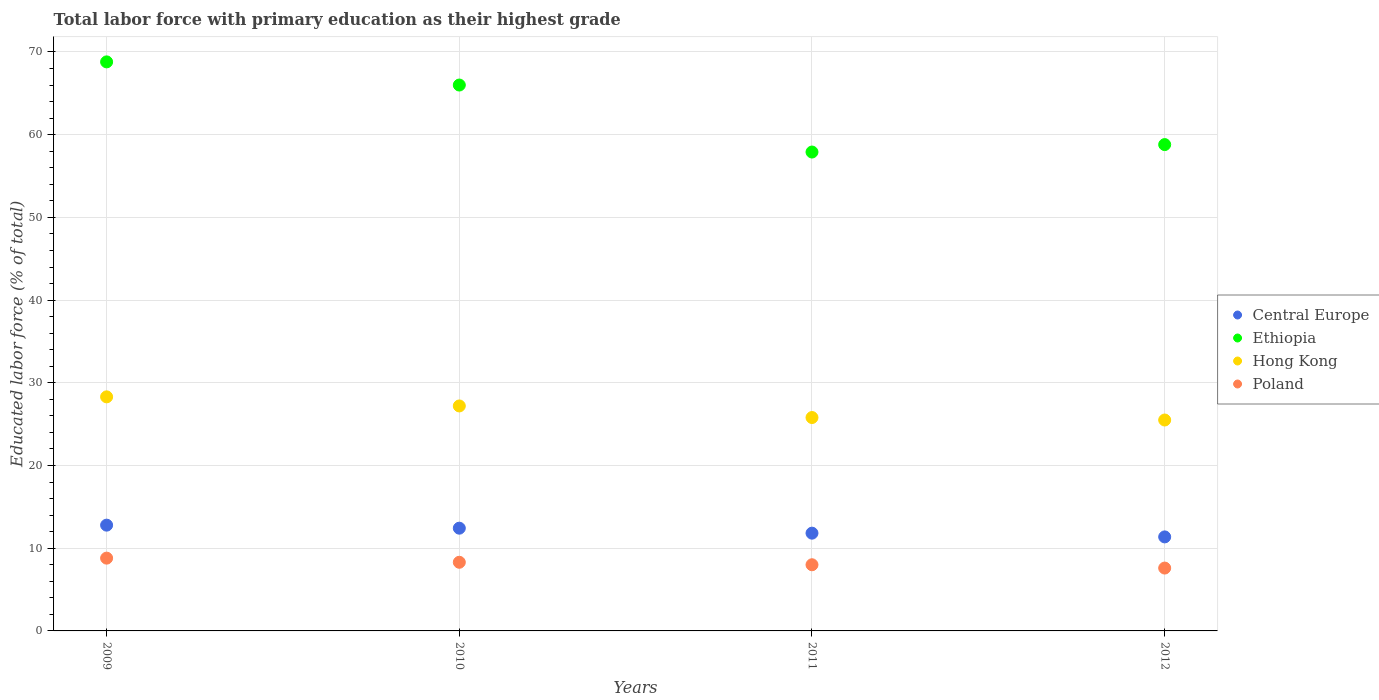How many different coloured dotlines are there?
Your answer should be compact. 4. Is the number of dotlines equal to the number of legend labels?
Keep it short and to the point. Yes. What is the percentage of total labor force with primary education in Ethiopia in 2012?
Make the answer very short. 58.8. Across all years, what is the maximum percentage of total labor force with primary education in Central Europe?
Keep it short and to the point. 12.79. Across all years, what is the minimum percentage of total labor force with primary education in Central Europe?
Provide a short and direct response. 11.37. In which year was the percentage of total labor force with primary education in Central Europe minimum?
Provide a short and direct response. 2012. What is the total percentage of total labor force with primary education in Poland in the graph?
Provide a succinct answer. 32.7. What is the difference between the percentage of total labor force with primary education in Poland in 2009 and that in 2011?
Offer a terse response. 0.8. What is the difference between the percentage of total labor force with primary education in Central Europe in 2011 and the percentage of total labor force with primary education in Ethiopia in 2010?
Your response must be concise. -54.18. What is the average percentage of total labor force with primary education in Hong Kong per year?
Provide a succinct answer. 26.7. In the year 2011, what is the difference between the percentage of total labor force with primary education in Central Europe and percentage of total labor force with primary education in Ethiopia?
Keep it short and to the point. -46.08. In how many years, is the percentage of total labor force with primary education in Poland greater than 28 %?
Ensure brevity in your answer.  0. What is the ratio of the percentage of total labor force with primary education in Ethiopia in 2010 to that in 2012?
Provide a succinct answer. 1.12. Is the difference between the percentage of total labor force with primary education in Central Europe in 2009 and 2011 greater than the difference between the percentage of total labor force with primary education in Ethiopia in 2009 and 2011?
Make the answer very short. No. What is the difference between the highest and the second highest percentage of total labor force with primary education in Central Europe?
Give a very brief answer. 0.37. What is the difference between the highest and the lowest percentage of total labor force with primary education in Poland?
Your response must be concise. 1.2. In how many years, is the percentage of total labor force with primary education in Central Europe greater than the average percentage of total labor force with primary education in Central Europe taken over all years?
Your response must be concise. 2. Is it the case that in every year, the sum of the percentage of total labor force with primary education in Central Europe and percentage of total labor force with primary education in Poland  is greater than the percentage of total labor force with primary education in Hong Kong?
Offer a very short reply. No. Is the percentage of total labor force with primary education in Ethiopia strictly greater than the percentage of total labor force with primary education in Poland over the years?
Make the answer very short. Yes. Is the percentage of total labor force with primary education in Central Europe strictly less than the percentage of total labor force with primary education in Hong Kong over the years?
Give a very brief answer. Yes. What is the difference between two consecutive major ticks on the Y-axis?
Keep it short and to the point. 10. Are the values on the major ticks of Y-axis written in scientific E-notation?
Make the answer very short. No. Does the graph contain any zero values?
Make the answer very short. No. How many legend labels are there?
Offer a terse response. 4. How are the legend labels stacked?
Your answer should be compact. Vertical. What is the title of the graph?
Make the answer very short. Total labor force with primary education as their highest grade. Does "Uzbekistan" appear as one of the legend labels in the graph?
Give a very brief answer. No. What is the label or title of the X-axis?
Your response must be concise. Years. What is the label or title of the Y-axis?
Give a very brief answer. Educated labor force (% of total). What is the Educated labor force (% of total) in Central Europe in 2009?
Your response must be concise. 12.79. What is the Educated labor force (% of total) of Ethiopia in 2009?
Offer a very short reply. 68.8. What is the Educated labor force (% of total) of Hong Kong in 2009?
Provide a succinct answer. 28.3. What is the Educated labor force (% of total) in Poland in 2009?
Keep it short and to the point. 8.8. What is the Educated labor force (% of total) of Central Europe in 2010?
Ensure brevity in your answer.  12.42. What is the Educated labor force (% of total) in Hong Kong in 2010?
Your answer should be very brief. 27.2. What is the Educated labor force (% of total) in Poland in 2010?
Make the answer very short. 8.3. What is the Educated labor force (% of total) in Central Europe in 2011?
Provide a succinct answer. 11.82. What is the Educated labor force (% of total) of Ethiopia in 2011?
Offer a very short reply. 57.9. What is the Educated labor force (% of total) in Hong Kong in 2011?
Ensure brevity in your answer.  25.8. What is the Educated labor force (% of total) of Central Europe in 2012?
Provide a succinct answer. 11.37. What is the Educated labor force (% of total) of Ethiopia in 2012?
Give a very brief answer. 58.8. What is the Educated labor force (% of total) of Poland in 2012?
Make the answer very short. 7.6. Across all years, what is the maximum Educated labor force (% of total) in Central Europe?
Your answer should be compact. 12.79. Across all years, what is the maximum Educated labor force (% of total) of Ethiopia?
Make the answer very short. 68.8. Across all years, what is the maximum Educated labor force (% of total) of Hong Kong?
Ensure brevity in your answer.  28.3. Across all years, what is the maximum Educated labor force (% of total) in Poland?
Ensure brevity in your answer.  8.8. Across all years, what is the minimum Educated labor force (% of total) of Central Europe?
Offer a terse response. 11.37. Across all years, what is the minimum Educated labor force (% of total) in Ethiopia?
Offer a very short reply. 57.9. Across all years, what is the minimum Educated labor force (% of total) in Poland?
Offer a terse response. 7.6. What is the total Educated labor force (% of total) of Central Europe in the graph?
Make the answer very short. 48.4. What is the total Educated labor force (% of total) of Ethiopia in the graph?
Provide a short and direct response. 251.5. What is the total Educated labor force (% of total) of Hong Kong in the graph?
Your answer should be compact. 106.8. What is the total Educated labor force (% of total) of Poland in the graph?
Offer a very short reply. 32.7. What is the difference between the Educated labor force (% of total) in Central Europe in 2009 and that in 2010?
Provide a succinct answer. 0.37. What is the difference between the Educated labor force (% of total) of Hong Kong in 2009 and that in 2010?
Keep it short and to the point. 1.1. What is the difference between the Educated labor force (% of total) in Central Europe in 2009 and that in 2011?
Make the answer very short. 0.97. What is the difference between the Educated labor force (% of total) in Ethiopia in 2009 and that in 2011?
Make the answer very short. 10.9. What is the difference between the Educated labor force (% of total) of Hong Kong in 2009 and that in 2011?
Offer a terse response. 2.5. What is the difference between the Educated labor force (% of total) in Poland in 2009 and that in 2011?
Keep it short and to the point. 0.8. What is the difference between the Educated labor force (% of total) in Central Europe in 2009 and that in 2012?
Your response must be concise. 1.42. What is the difference between the Educated labor force (% of total) of Poland in 2009 and that in 2012?
Give a very brief answer. 1.2. What is the difference between the Educated labor force (% of total) of Central Europe in 2010 and that in 2011?
Your response must be concise. 0.6. What is the difference between the Educated labor force (% of total) in Poland in 2010 and that in 2011?
Make the answer very short. 0.3. What is the difference between the Educated labor force (% of total) in Central Europe in 2010 and that in 2012?
Give a very brief answer. 1.05. What is the difference between the Educated labor force (% of total) of Ethiopia in 2010 and that in 2012?
Ensure brevity in your answer.  7.2. What is the difference between the Educated labor force (% of total) in Central Europe in 2011 and that in 2012?
Provide a succinct answer. 0.45. What is the difference between the Educated labor force (% of total) of Ethiopia in 2011 and that in 2012?
Offer a terse response. -0.9. What is the difference between the Educated labor force (% of total) in Central Europe in 2009 and the Educated labor force (% of total) in Ethiopia in 2010?
Make the answer very short. -53.21. What is the difference between the Educated labor force (% of total) of Central Europe in 2009 and the Educated labor force (% of total) of Hong Kong in 2010?
Your answer should be compact. -14.41. What is the difference between the Educated labor force (% of total) in Central Europe in 2009 and the Educated labor force (% of total) in Poland in 2010?
Ensure brevity in your answer.  4.49. What is the difference between the Educated labor force (% of total) of Ethiopia in 2009 and the Educated labor force (% of total) of Hong Kong in 2010?
Offer a terse response. 41.6. What is the difference between the Educated labor force (% of total) of Ethiopia in 2009 and the Educated labor force (% of total) of Poland in 2010?
Provide a short and direct response. 60.5. What is the difference between the Educated labor force (% of total) of Central Europe in 2009 and the Educated labor force (% of total) of Ethiopia in 2011?
Ensure brevity in your answer.  -45.11. What is the difference between the Educated labor force (% of total) of Central Europe in 2009 and the Educated labor force (% of total) of Hong Kong in 2011?
Your response must be concise. -13.01. What is the difference between the Educated labor force (% of total) in Central Europe in 2009 and the Educated labor force (% of total) in Poland in 2011?
Provide a short and direct response. 4.79. What is the difference between the Educated labor force (% of total) in Ethiopia in 2009 and the Educated labor force (% of total) in Hong Kong in 2011?
Offer a very short reply. 43. What is the difference between the Educated labor force (% of total) in Ethiopia in 2009 and the Educated labor force (% of total) in Poland in 2011?
Keep it short and to the point. 60.8. What is the difference between the Educated labor force (% of total) of Hong Kong in 2009 and the Educated labor force (% of total) of Poland in 2011?
Your response must be concise. 20.3. What is the difference between the Educated labor force (% of total) of Central Europe in 2009 and the Educated labor force (% of total) of Ethiopia in 2012?
Your response must be concise. -46.01. What is the difference between the Educated labor force (% of total) of Central Europe in 2009 and the Educated labor force (% of total) of Hong Kong in 2012?
Your response must be concise. -12.71. What is the difference between the Educated labor force (% of total) of Central Europe in 2009 and the Educated labor force (% of total) of Poland in 2012?
Ensure brevity in your answer.  5.19. What is the difference between the Educated labor force (% of total) in Ethiopia in 2009 and the Educated labor force (% of total) in Hong Kong in 2012?
Your response must be concise. 43.3. What is the difference between the Educated labor force (% of total) of Ethiopia in 2009 and the Educated labor force (% of total) of Poland in 2012?
Offer a very short reply. 61.2. What is the difference between the Educated labor force (% of total) in Hong Kong in 2009 and the Educated labor force (% of total) in Poland in 2012?
Offer a very short reply. 20.7. What is the difference between the Educated labor force (% of total) in Central Europe in 2010 and the Educated labor force (% of total) in Ethiopia in 2011?
Provide a succinct answer. -45.48. What is the difference between the Educated labor force (% of total) of Central Europe in 2010 and the Educated labor force (% of total) of Hong Kong in 2011?
Ensure brevity in your answer.  -13.38. What is the difference between the Educated labor force (% of total) of Central Europe in 2010 and the Educated labor force (% of total) of Poland in 2011?
Give a very brief answer. 4.42. What is the difference between the Educated labor force (% of total) of Ethiopia in 2010 and the Educated labor force (% of total) of Hong Kong in 2011?
Your answer should be compact. 40.2. What is the difference between the Educated labor force (% of total) of Ethiopia in 2010 and the Educated labor force (% of total) of Poland in 2011?
Keep it short and to the point. 58. What is the difference between the Educated labor force (% of total) of Central Europe in 2010 and the Educated labor force (% of total) of Ethiopia in 2012?
Give a very brief answer. -46.38. What is the difference between the Educated labor force (% of total) of Central Europe in 2010 and the Educated labor force (% of total) of Hong Kong in 2012?
Offer a very short reply. -13.08. What is the difference between the Educated labor force (% of total) of Central Europe in 2010 and the Educated labor force (% of total) of Poland in 2012?
Keep it short and to the point. 4.82. What is the difference between the Educated labor force (% of total) of Ethiopia in 2010 and the Educated labor force (% of total) of Hong Kong in 2012?
Ensure brevity in your answer.  40.5. What is the difference between the Educated labor force (% of total) in Ethiopia in 2010 and the Educated labor force (% of total) in Poland in 2012?
Keep it short and to the point. 58.4. What is the difference between the Educated labor force (% of total) of Hong Kong in 2010 and the Educated labor force (% of total) of Poland in 2012?
Provide a succinct answer. 19.6. What is the difference between the Educated labor force (% of total) in Central Europe in 2011 and the Educated labor force (% of total) in Ethiopia in 2012?
Your answer should be compact. -46.98. What is the difference between the Educated labor force (% of total) of Central Europe in 2011 and the Educated labor force (% of total) of Hong Kong in 2012?
Keep it short and to the point. -13.68. What is the difference between the Educated labor force (% of total) in Central Europe in 2011 and the Educated labor force (% of total) in Poland in 2012?
Make the answer very short. 4.22. What is the difference between the Educated labor force (% of total) in Ethiopia in 2011 and the Educated labor force (% of total) in Hong Kong in 2012?
Keep it short and to the point. 32.4. What is the difference between the Educated labor force (% of total) of Ethiopia in 2011 and the Educated labor force (% of total) of Poland in 2012?
Your answer should be compact. 50.3. What is the difference between the Educated labor force (% of total) of Hong Kong in 2011 and the Educated labor force (% of total) of Poland in 2012?
Make the answer very short. 18.2. What is the average Educated labor force (% of total) of Central Europe per year?
Give a very brief answer. 12.1. What is the average Educated labor force (% of total) in Ethiopia per year?
Ensure brevity in your answer.  62.88. What is the average Educated labor force (% of total) of Hong Kong per year?
Offer a very short reply. 26.7. What is the average Educated labor force (% of total) of Poland per year?
Offer a very short reply. 8.18. In the year 2009, what is the difference between the Educated labor force (% of total) of Central Europe and Educated labor force (% of total) of Ethiopia?
Your response must be concise. -56.01. In the year 2009, what is the difference between the Educated labor force (% of total) in Central Europe and Educated labor force (% of total) in Hong Kong?
Your answer should be very brief. -15.51. In the year 2009, what is the difference between the Educated labor force (% of total) of Central Europe and Educated labor force (% of total) of Poland?
Give a very brief answer. 3.99. In the year 2009, what is the difference between the Educated labor force (% of total) of Ethiopia and Educated labor force (% of total) of Hong Kong?
Offer a terse response. 40.5. In the year 2009, what is the difference between the Educated labor force (% of total) of Ethiopia and Educated labor force (% of total) of Poland?
Ensure brevity in your answer.  60. In the year 2009, what is the difference between the Educated labor force (% of total) in Hong Kong and Educated labor force (% of total) in Poland?
Keep it short and to the point. 19.5. In the year 2010, what is the difference between the Educated labor force (% of total) of Central Europe and Educated labor force (% of total) of Ethiopia?
Offer a very short reply. -53.58. In the year 2010, what is the difference between the Educated labor force (% of total) in Central Europe and Educated labor force (% of total) in Hong Kong?
Your answer should be very brief. -14.78. In the year 2010, what is the difference between the Educated labor force (% of total) in Central Europe and Educated labor force (% of total) in Poland?
Ensure brevity in your answer.  4.12. In the year 2010, what is the difference between the Educated labor force (% of total) in Ethiopia and Educated labor force (% of total) in Hong Kong?
Provide a succinct answer. 38.8. In the year 2010, what is the difference between the Educated labor force (% of total) in Ethiopia and Educated labor force (% of total) in Poland?
Your response must be concise. 57.7. In the year 2011, what is the difference between the Educated labor force (% of total) in Central Europe and Educated labor force (% of total) in Ethiopia?
Keep it short and to the point. -46.08. In the year 2011, what is the difference between the Educated labor force (% of total) in Central Europe and Educated labor force (% of total) in Hong Kong?
Provide a short and direct response. -13.98. In the year 2011, what is the difference between the Educated labor force (% of total) of Central Europe and Educated labor force (% of total) of Poland?
Your answer should be very brief. 3.82. In the year 2011, what is the difference between the Educated labor force (% of total) in Ethiopia and Educated labor force (% of total) in Hong Kong?
Your answer should be very brief. 32.1. In the year 2011, what is the difference between the Educated labor force (% of total) of Ethiopia and Educated labor force (% of total) of Poland?
Your answer should be compact. 49.9. In the year 2011, what is the difference between the Educated labor force (% of total) of Hong Kong and Educated labor force (% of total) of Poland?
Your response must be concise. 17.8. In the year 2012, what is the difference between the Educated labor force (% of total) in Central Europe and Educated labor force (% of total) in Ethiopia?
Your response must be concise. -47.43. In the year 2012, what is the difference between the Educated labor force (% of total) in Central Europe and Educated labor force (% of total) in Hong Kong?
Offer a terse response. -14.13. In the year 2012, what is the difference between the Educated labor force (% of total) of Central Europe and Educated labor force (% of total) of Poland?
Ensure brevity in your answer.  3.77. In the year 2012, what is the difference between the Educated labor force (% of total) of Ethiopia and Educated labor force (% of total) of Hong Kong?
Your answer should be compact. 33.3. In the year 2012, what is the difference between the Educated labor force (% of total) of Ethiopia and Educated labor force (% of total) of Poland?
Provide a succinct answer. 51.2. In the year 2012, what is the difference between the Educated labor force (% of total) of Hong Kong and Educated labor force (% of total) of Poland?
Make the answer very short. 17.9. What is the ratio of the Educated labor force (% of total) of Central Europe in 2009 to that in 2010?
Ensure brevity in your answer.  1.03. What is the ratio of the Educated labor force (% of total) of Ethiopia in 2009 to that in 2010?
Offer a very short reply. 1.04. What is the ratio of the Educated labor force (% of total) in Hong Kong in 2009 to that in 2010?
Your response must be concise. 1.04. What is the ratio of the Educated labor force (% of total) in Poland in 2009 to that in 2010?
Provide a succinct answer. 1.06. What is the ratio of the Educated labor force (% of total) in Central Europe in 2009 to that in 2011?
Make the answer very short. 1.08. What is the ratio of the Educated labor force (% of total) in Ethiopia in 2009 to that in 2011?
Provide a succinct answer. 1.19. What is the ratio of the Educated labor force (% of total) in Hong Kong in 2009 to that in 2011?
Make the answer very short. 1.1. What is the ratio of the Educated labor force (% of total) of Poland in 2009 to that in 2011?
Make the answer very short. 1.1. What is the ratio of the Educated labor force (% of total) in Ethiopia in 2009 to that in 2012?
Ensure brevity in your answer.  1.17. What is the ratio of the Educated labor force (% of total) in Hong Kong in 2009 to that in 2012?
Provide a short and direct response. 1.11. What is the ratio of the Educated labor force (% of total) of Poland in 2009 to that in 2012?
Your answer should be very brief. 1.16. What is the ratio of the Educated labor force (% of total) of Central Europe in 2010 to that in 2011?
Make the answer very short. 1.05. What is the ratio of the Educated labor force (% of total) of Ethiopia in 2010 to that in 2011?
Provide a short and direct response. 1.14. What is the ratio of the Educated labor force (% of total) of Hong Kong in 2010 to that in 2011?
Offer a terse response. 1.05. What is the ratio of the Educated labor force (% of total) in Poland in 2010 to that in 2011?
Ensure brevity in your answer.  1.04. What is the ratio of the Educated labor force (% of total) in Central Europe in 2010 to that in 2012?
Provide a short and direct response. 1.09. What is the ratio of the Educated labor force (% of total) in Ethiopia in 2010 to that in 2012?
Offer a terse response. 1.12. What is the ratio of the Educated labor force (% of total) in Hong Kong in 2010 to that in 2012?
Provide a short and direct response. 1.07. What is the ratio of the Educated labor force (% of total) of Poland in 2010 to that in 2012?
Provide a short and direct response. 1.09. What is the ratio of the Educated labor force (% of total) of Central Europe in 2011 to that in 2012?
Make the answer very short. 1.04. What is the ratio of the Educated labor force (% of total) of Ethiopia in 2011 to that in 2012?
Keep it short and to the point. 0.98. What is the ratio of the Educated labor force (% of total) in Hong Kong in 2011 to that in 2012?
Provide a succinct answer. 1.01. What is the ratio of the Educated labor force (% of total) in Poland in 2011 to that in 2012?
Ensure brevity in your answer.  1.05. What is the difference between the highest and the second highest Educated labor force (% of total) of Central Europe?
Offer a very short reply. 0.37. What is the difference between the highest and the second highest Educated labor force (% of total) in Hong Kong?
Provide a short and direct response. 1.1. What is the difference between the highest and the second highest Educated labor force (% of total) in Poland?
Your response must be concise. 0.5. What is the difference between the highest and the lowest Educated labor force (% of total) of Central Europe?
Your answer should be very brief. 1.42. What is the difference between the highest and the lowest Educated labor force (% of total) in Hong Kong?
Ensure brevity in your answer.  2.8. 